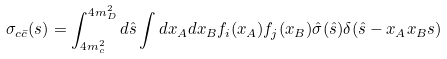Convert formula to latex. <formula><loc_0><loc_0><loc_500><loc_500>\sigma _ { c \bar { c } } ( s ) = \int _ { 4 m _ { c } ^ { 2 } } ^ { 4 m _ { D } ^ { 2 } } d \hat { s } \int d x _ { A } d x _ { B } f _ { i } ( x _ { A } ) f _ { j } ( x _ { B } ) \hat { \sigma } ( \hat { s } ) \delta ( \hat { s } - x _ { A } x _ { B } s )</formula> 